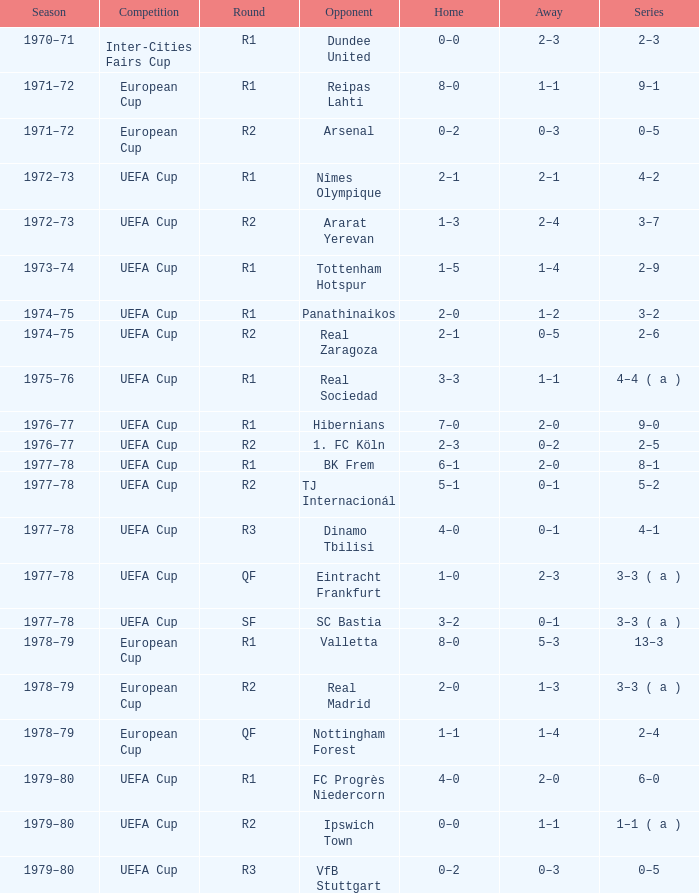Which stage features a contest in the uefa cup, and a sequence of 5-2? R2. 